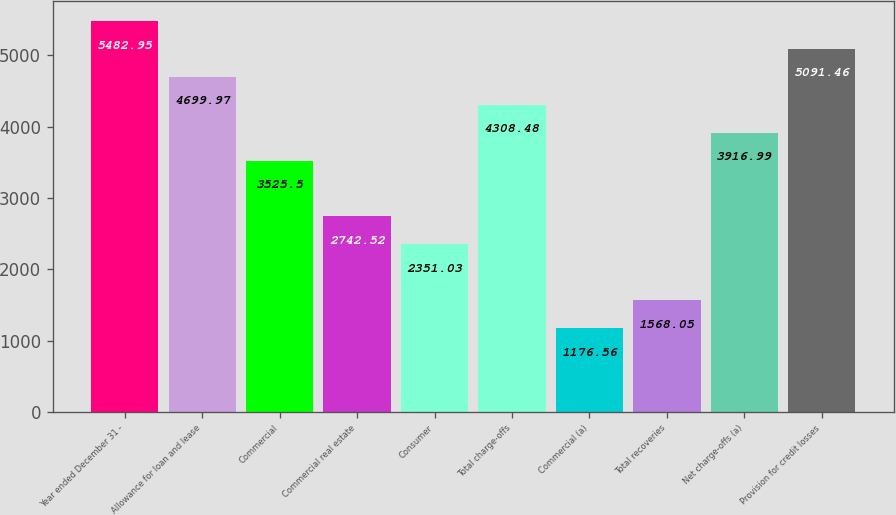Convert chart. <chart><loc_0><loc_0><loc_500><loc_500><bar_chart><fcel>Year ended December 31 -<fcel>Allowance for loan and lease<fcel>Commercial<fcel>Commercial real estate<fcel>Consumer<fcel>Total charge-offs<fcel>Commercial (a)<fcel>Total recoveries<fcel>Net charge-offs (a)<fcel>Provision for credit losses<nl><fcel>5482.95<fcel>4699.97<fcel>3525.5<fcel>2742.52<fcel>2351.03<fcel>4308.48<fcel>1176.56<fcel>1568.05<fcel>3916.99<fcel>5091.46<nl></chart> 